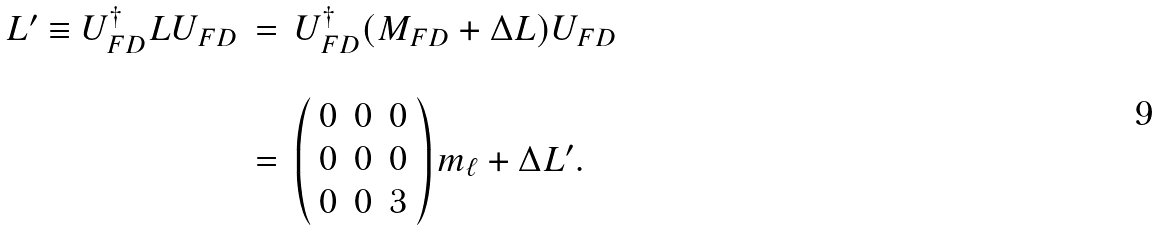<formula> <loc_0><loc_0><loc_500><loc_500>\begin{array} { l c l } L ^ { \prime } \equiv U _ { F D } ^ { \dag } L U _ { F D } & = & U _ { F D } ^ { \dag } ( M _ { F D } + \Delta L ) U _ { F D } \\ & & \\ & = & \left ( \begin{array} { c c c } 0 & 0 & 0 \\ 0 & 0 & 0 \\ 0 & 0 & 3 \end{array} \right ) m _ { \ell } + \Delta L ^ { \prime } . \end{array}</formula> 